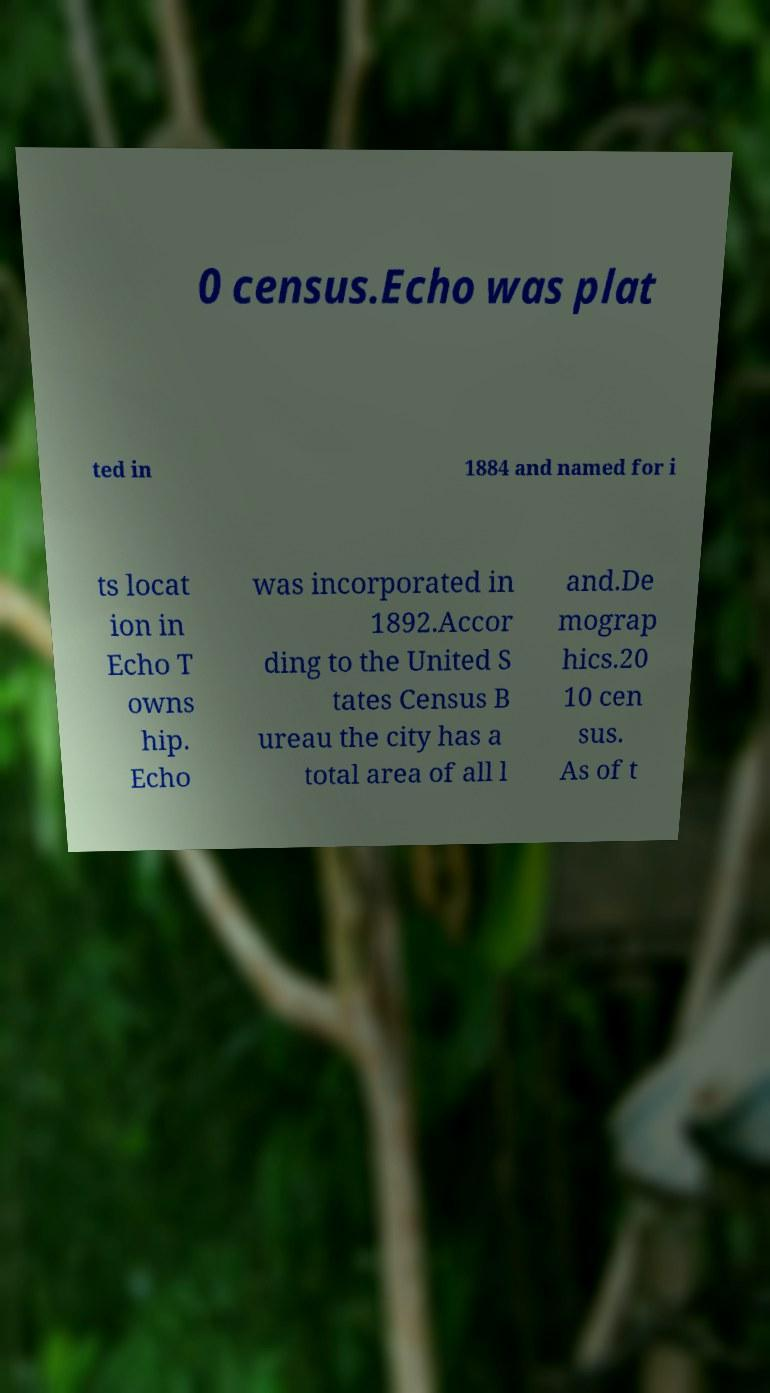Could you assist in decoding the text presented in this image and type it out clearly? 0 census.Echo was plat ted in 1884 and named for i ts locat ion in Echo T owns hip. Echo was incorporated in 1892.Accor ding to the United S tates Census B ureau the city has a total area of all l and.De mograp hics.20 10 cen sus. As of t 